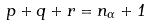Convert formula to latex. <formula><loc_0><loc_0><loc_500><loc_500>p + q + r = n _ { \Gamma } + 1</formula> 